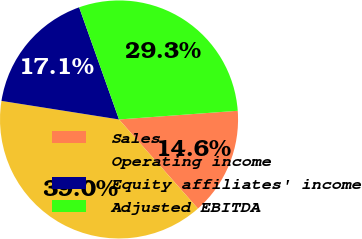<chart> <loc_0><loc_0><loc_500><loc_500><pie_chart><fcel>Sales<fcel>Operating income<fcel>Equity affiliates' income<fcel>Adjusted EBITDA<nl><fcel>14.63%<fcel>39.02%<fcel>17.07%<fcel>29.27%<nl></chart> 